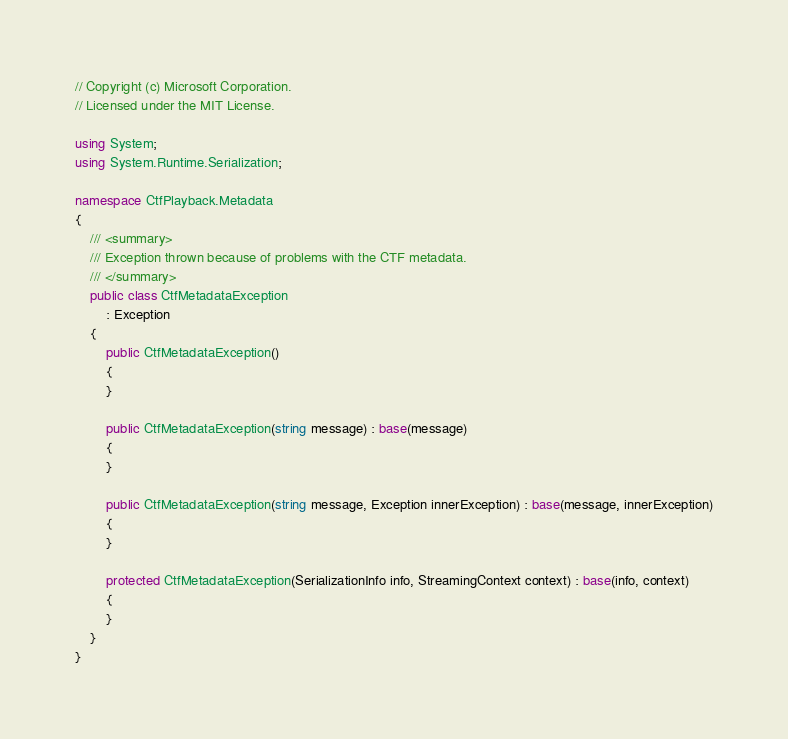<code> <loc_0><loc_0><loc_500><loc_500><_C#_>// Copyright (c) Microsoft Corporation.
// Licensed under the MIT License.

using System;
using System.Runtime.Serialization;

namespace CtfPlayback.Metadata
{
    /// <summary>
    /// Exception thrown because of problems with the CTF metadata.
    /// </summary>
    public class CtfMetadataException 
        : Exception
    {
        public CtfMetadataException()
        {
        }

        public CtfMetadataException(string message) : base(message)
        {
        }

        public CtfMetadataException(string message, Exception innerException) : base(message, innerException)
        {
        }

        protected CtfMetadataException(SerializationInfo info, StreamingContext context) : base(info, context)
        {
        }
    }
}</code> 